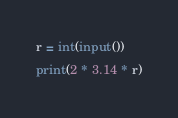Convert code to text. <code><loc_0><loc_0><loc_500><loc_500><_Python_>r = int(input())
print(2 * 3.14 * r)</code> 